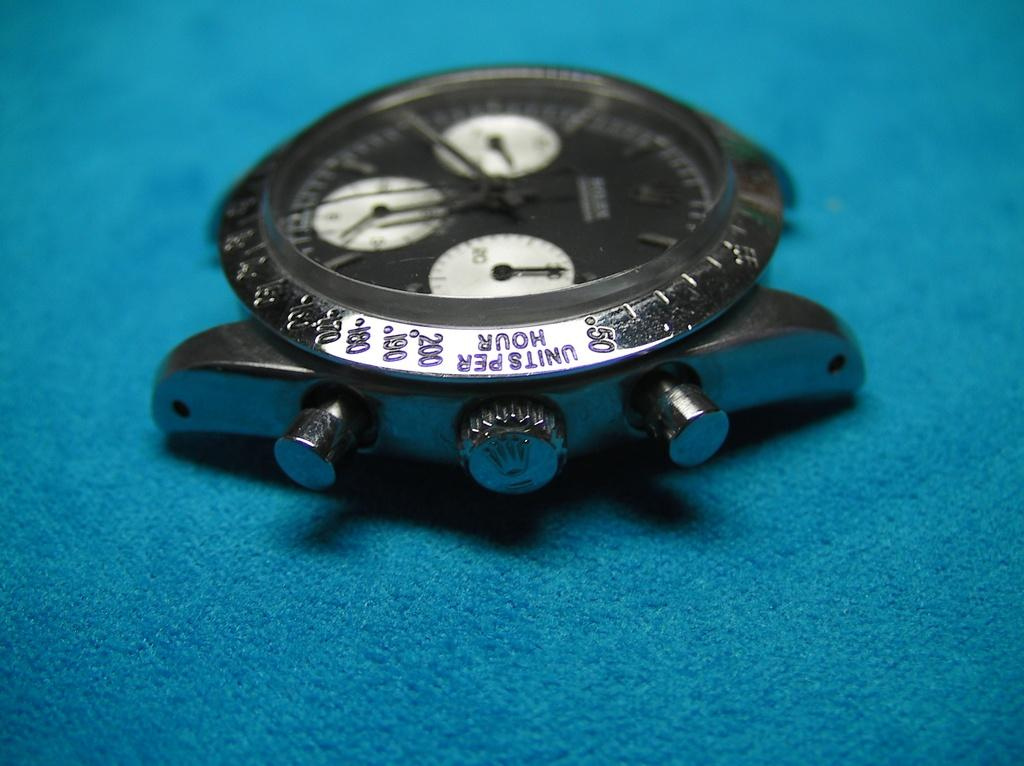<image>
Share a concise interpretation of the image provided. A silver watch with numbers around the outter edge with the word units per hour engraved at the edge. 